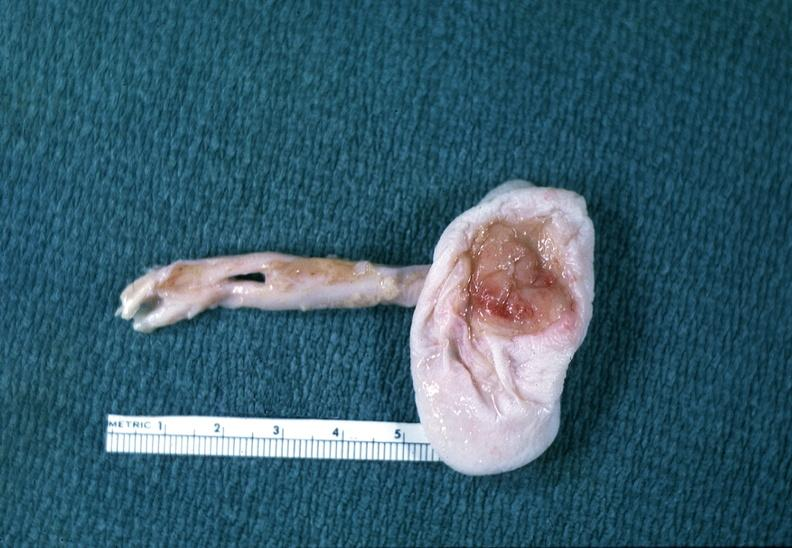s nervous present?
Answer the question using a single word or phrase. Yes 